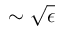Convert formula to latex. <formula><loc_0><loc_0><loc_500><loc_500>\sim \sqrt { \epsilon }</formula> 